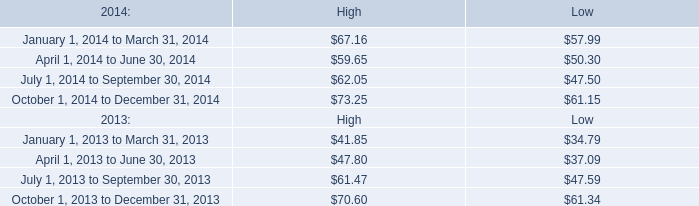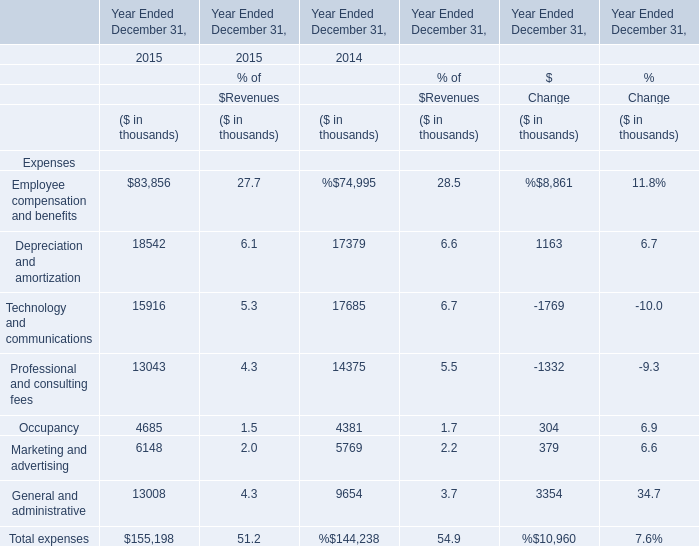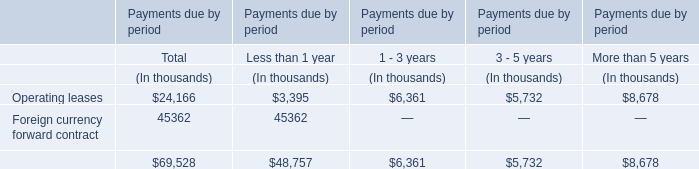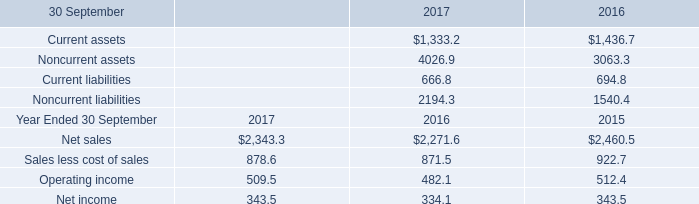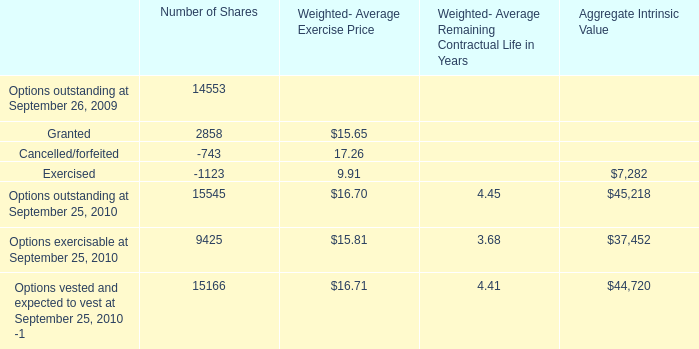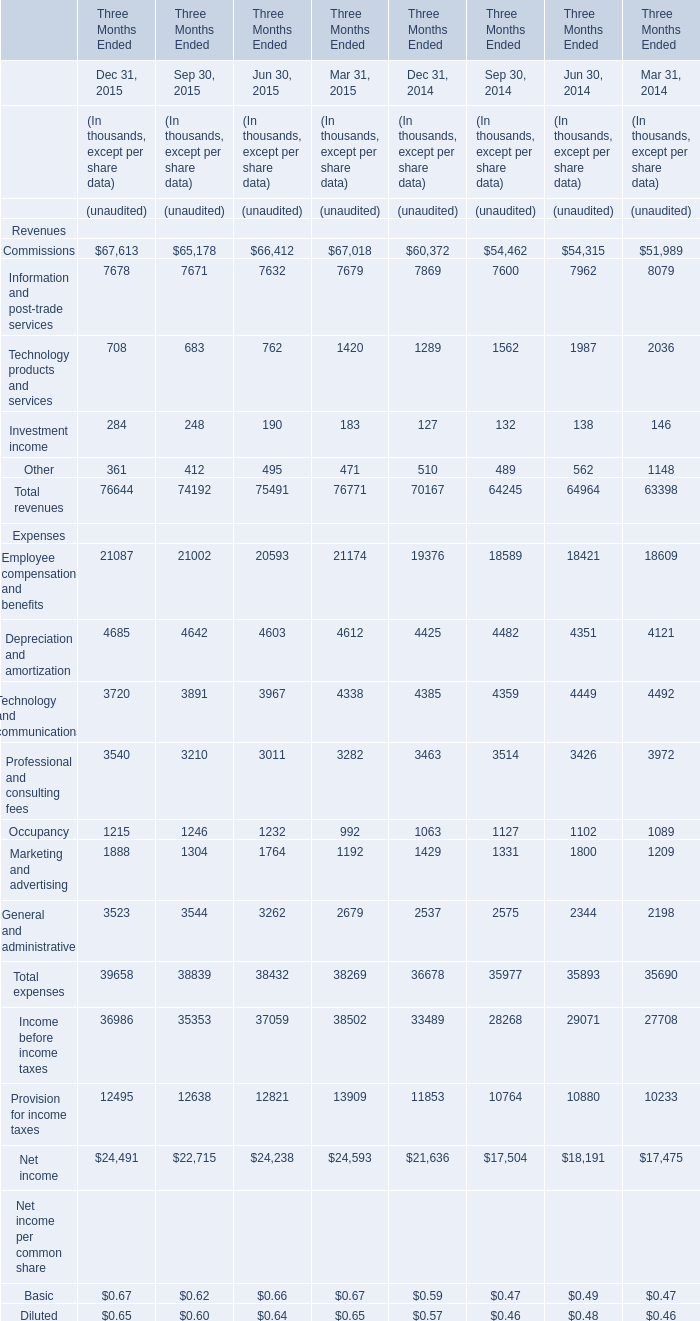by how much did the high of mktx stock increase from april 12 , 2014 to march 31 , 2014? 
Computations: ((67.16 - 59.65) / 59.65)
Answer: 0.1259. 